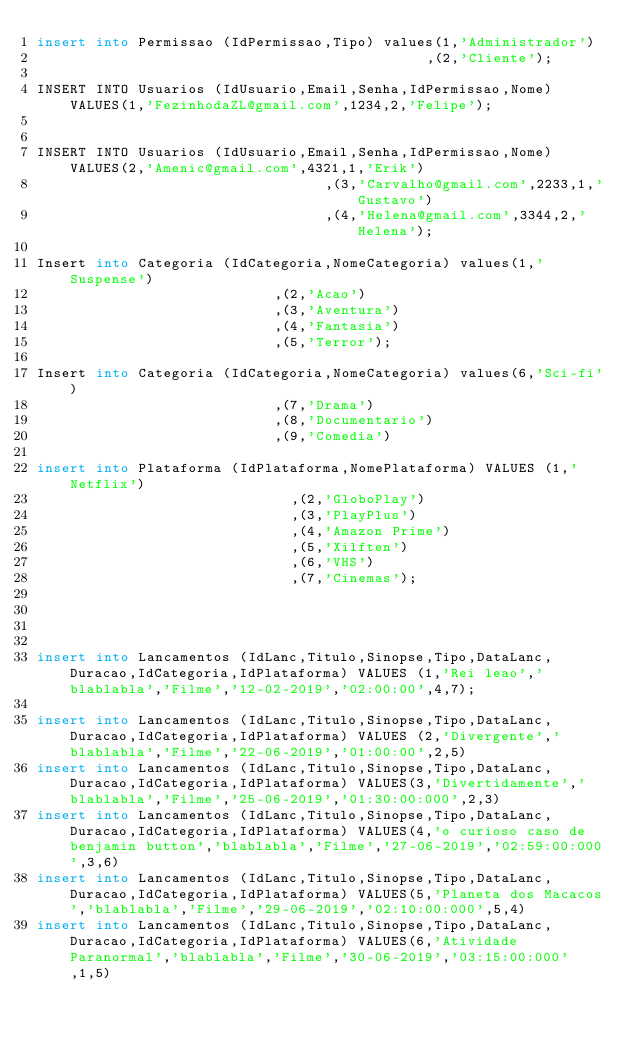Convert code to text. <code><loc_0><loc_0><loc_500><loc_500><_SQL_>insert into Permissao (IdPermissao,Tipo) values(1,'Administrador')
                                              ,(2,'Cliente'); 

INSERT INTO Usuarios (IdUsuario,Email,Senha,IdPermissao,Nome) VALUES(1,'FezinhodaZL@gmail.com',1234,2,'Felipe');
																	

INSERT INTO Usuarios (IdUsuario,Email,Senha,IdPermissao,Nome) VALUES(2,'Amenic@gmail.com',4321,1,'Erik')
																	,(3,'Carvalho@gmail.com',2233,1,'Gustavo')
																	,(4,'Helena@gmail.com',3344,2,'Helena');

Insert into Categoria (IdCategoria,NomeCategoria) values(1,'Suspense')
														,(2,'Acao')
														,(3,'Aventura')
														,(4,'Fantasia')
														,(5,'Terror');

Insert into Categoria (IdCategoria,NomeCategoria) values(6,'Sci-fi')
														,(7,'Drama')
														,(8,'Documentario')
														,(9,'Comedia')

insert into Plataforma (IdPlataforma,NomePlataforma) VALUES (1,'Netflix')
															,(2,'GloboPlay')
															,(3,'PlayPlus')
															,(4,'Amazon Prime')
															,(5,'Xilften')
															,(6,'VHS')
															,(7,'Cinemas');
													



insert into Lancamentos (IdLanc,Titulo,Sinopse,Tipo,DataLanc,Duracao,IdCategoria,IdPlataforma) VALUES (1,'Rei leao','blablabla','Filme','12-02-2019','02:00:00',4,7);

insert into Lancamentos (IdLanc,Titulo,Sinopse,Tipo,DataLanc,Duracao,IdCategoria,IdPlataforma) VALUES (2,'Divergente','blablabla','Filme','22-06-2019','01:00:00',2,5)
insert into Lancamentos (IdLanc,Titulo,Sinopse,Tipo,DataLanc,Duracao,IdCategoria,IdPlataforma) VALUES(3,'Divertidamente','blablabla','Filme','25-06-2019','01:30:00:000',2,3)
insert into Lancamentos (IdLanc,Titulo,Sinopse,Tipo,DataLanc,Duracao,IdCategoria,IdPlataforma) VALUES(4,'o curioso caso de benjamin button','blablabla','Filme','27-06-2019','02:59:00:000',3,6)
insert into Lancamentos (IdLanc,Titulo,Sinopse,Tipo,DataLanc,Duracao,IdCategoria,IdPlataforma) VALUES(5,'Planeta dos Macacos','blablabla','Filme','29-06-2019','02:10:00:000',5,4)
insert into Lancamentos (IdLanc,Titulo,Sinopse,Tipo,DataLanc,Duracao,IdCategoria,IdPlataforma) VALUES(6,'Atividade Paranormal','blablabla','Filme','30-06-2019','03:15:00:000',1,5)</code> 